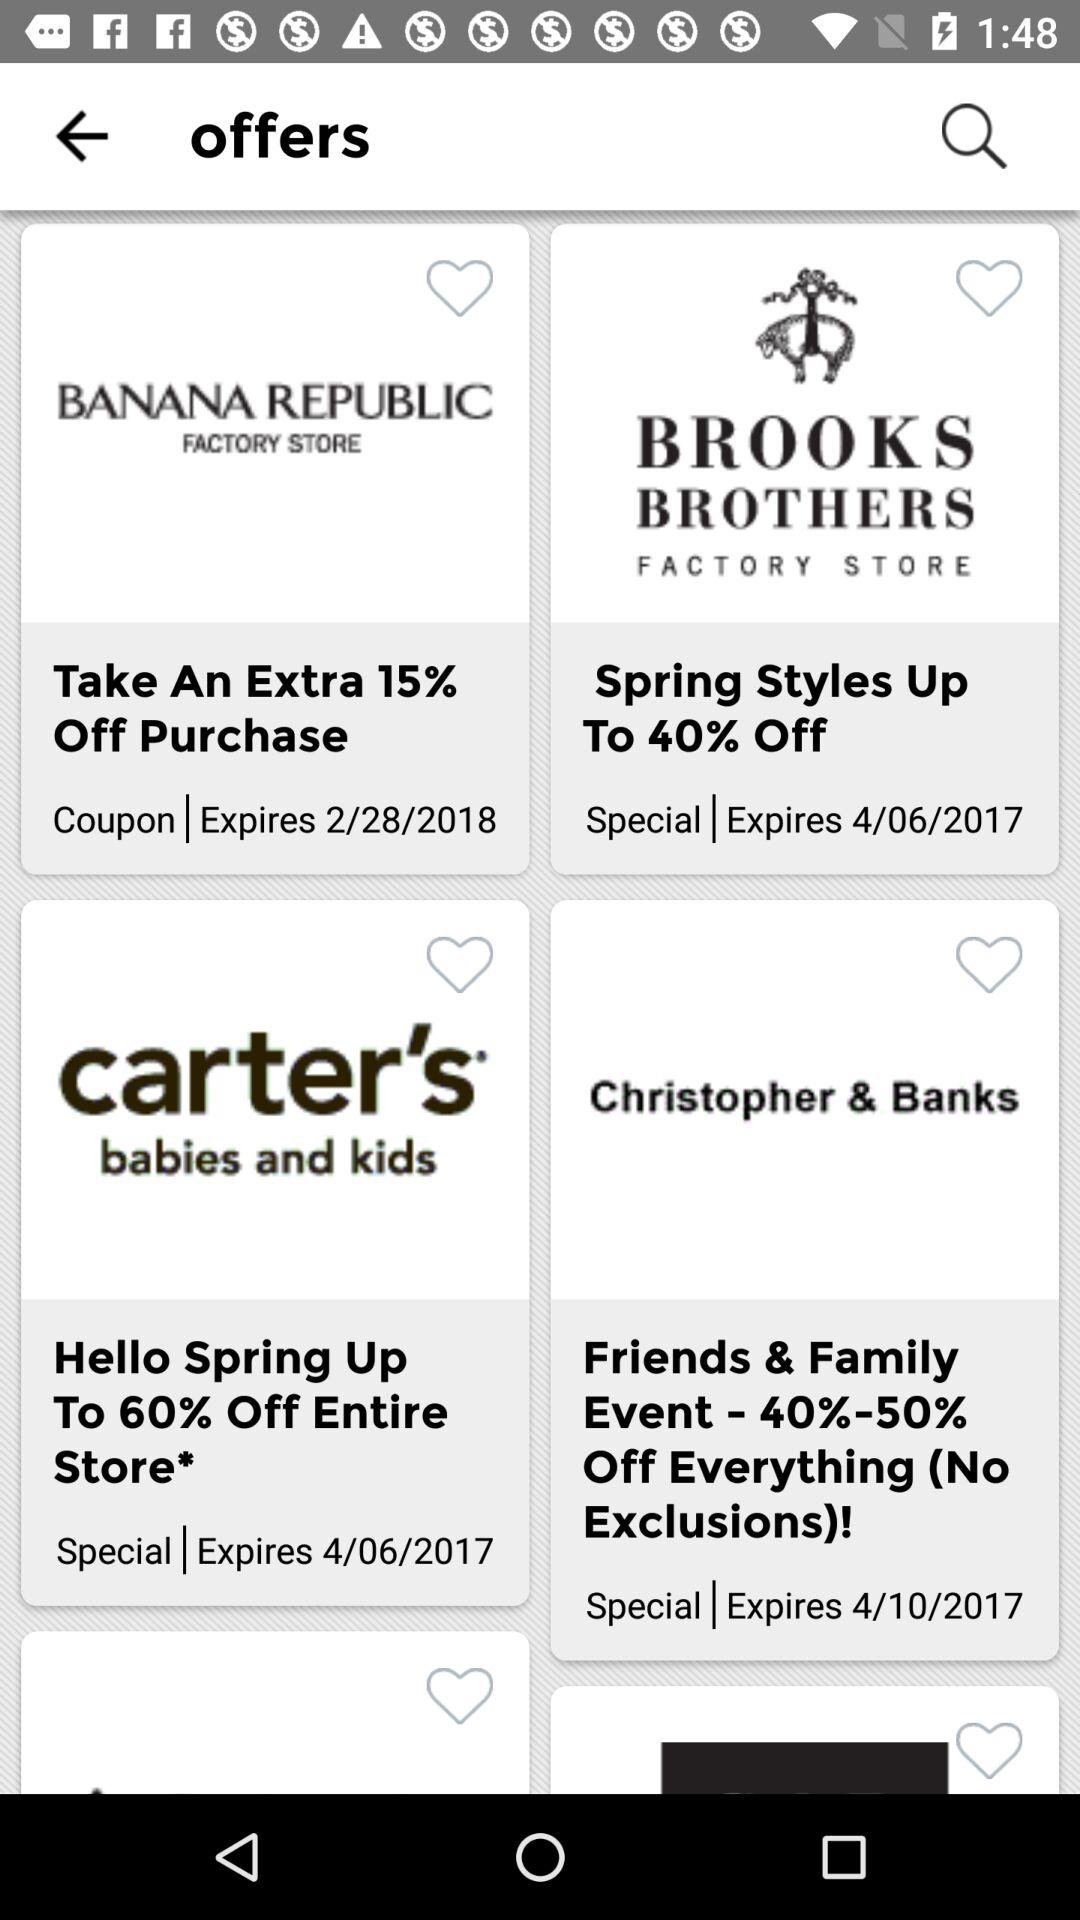What is the expiration date of the offer at the "BROOKS BROTHERS FACTORY STORE"? The expiration date is April 6, 2017. 